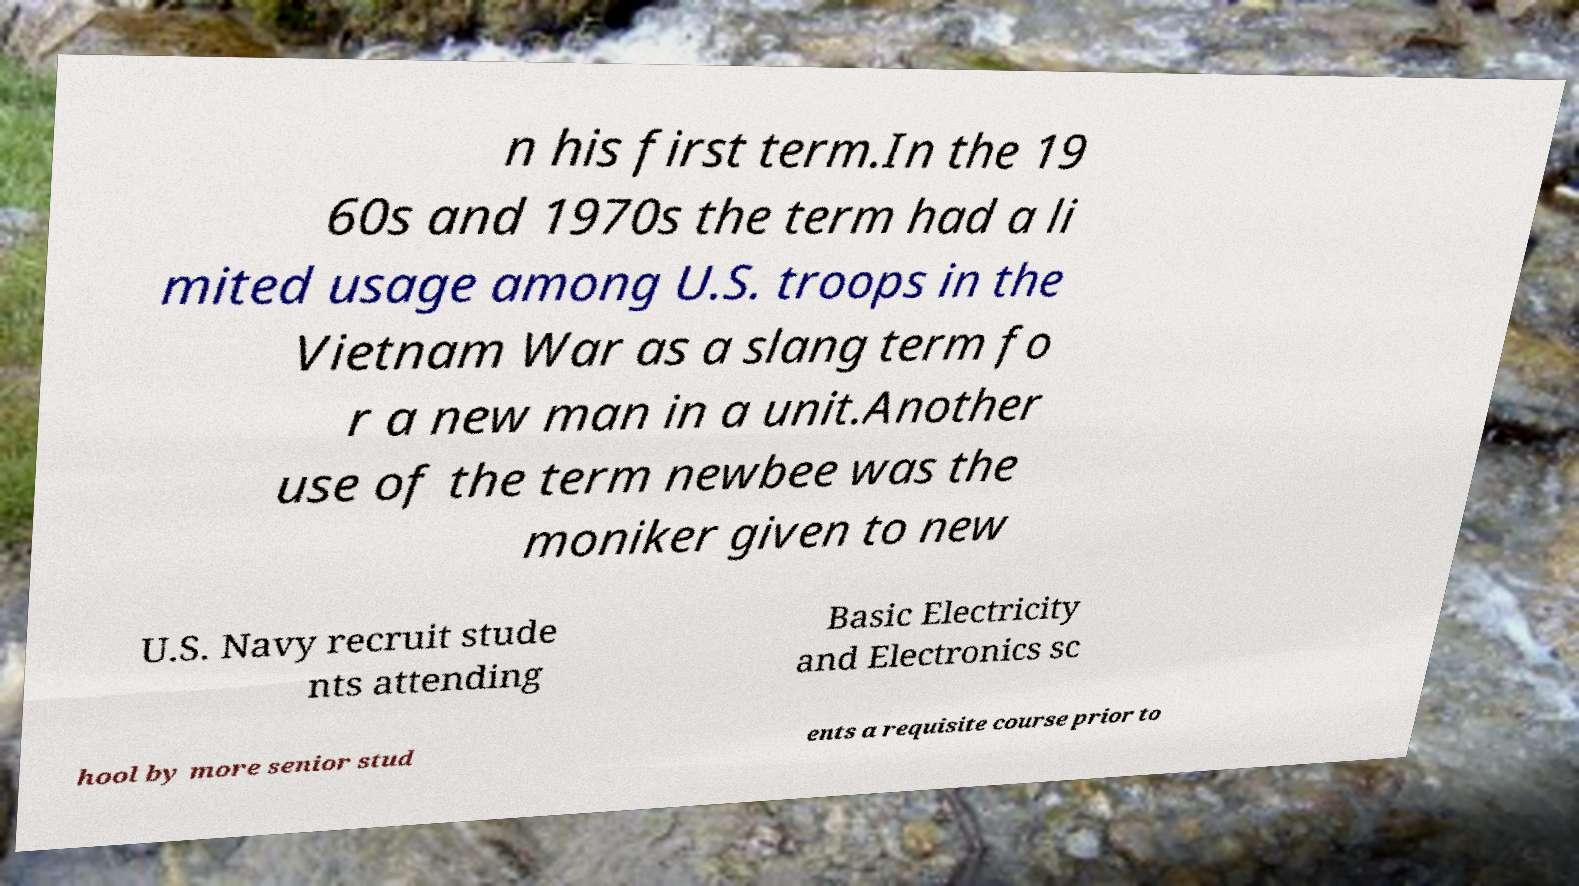There's text embedded in this image that I need extracted. Can you transcribe it verbatim? n his first term.In the 19 60s and 1970s the term had a li mited usage among U.S. troops in the Vietnam War as a slang term fo r a new man in a unit.Another use of the term newbee was the moniker given to new U.S. Navy recruit stude nts attending Basic Electricity and Electronics sc hool by more senior stud ents a requisite course prior to 